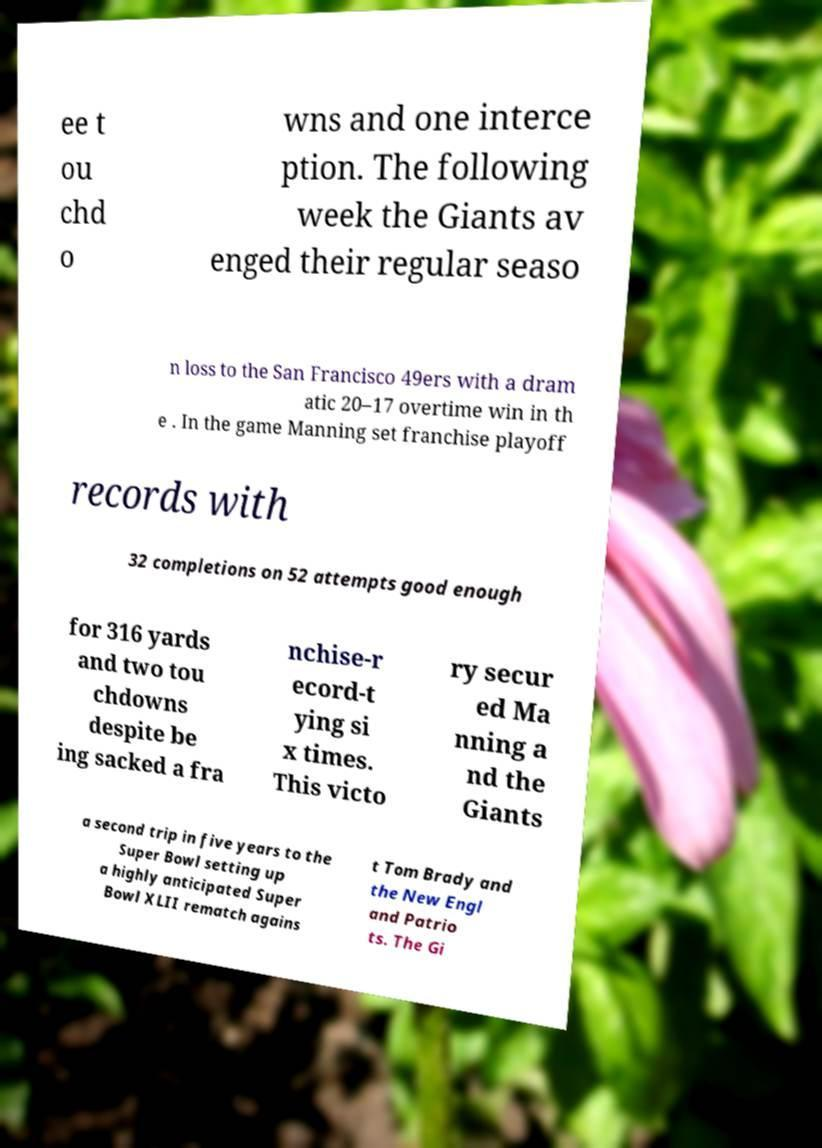What messages or text are displayed in this image? I need them in a readable, typed format. ee t ou chd o wns and one interce ption. The following week the Giants av enged their regular seaso n loss to the San Francisco 49ers with a dram atic 20–17 overtime win in th e . In the game Manning set franchise playoff records with 32 completions on 52 attempts good enough for 316 yards and two tou chdowns despite be ing sacked a fra nchise-r ecord-t ying si x times. This victo ry secur ed Ma nning a nd the Giants a second trip in five years to the Super Bowl setting up a highly anticipated Super Bowl XLII rematch agains t Tom Brady and the New Engl and Patrio ts. The Gi 